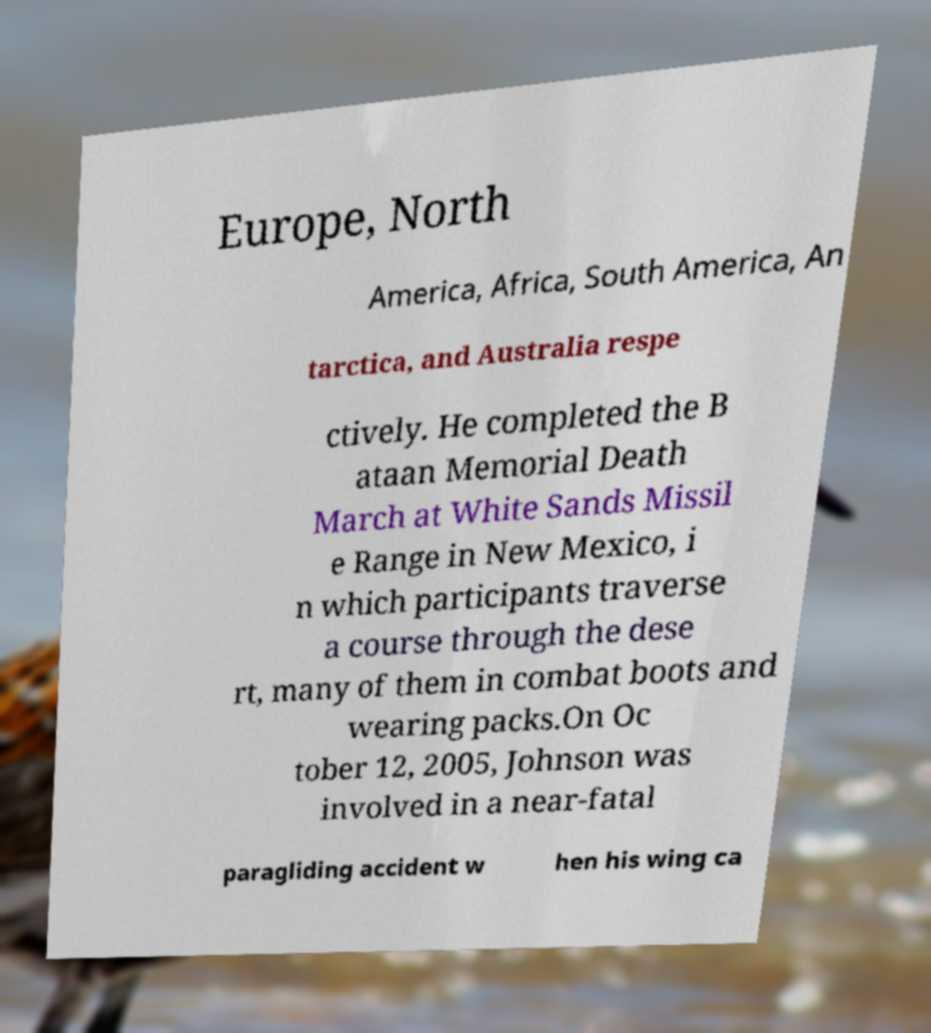Could you assist in decoding the text presented in this image and type it out clearly? Europe, North America, Africa, South America, An tarctica, and Australia respe ctively. He completed the B ataan Memorial Death March at White Sands Missil e Range in New Mexico, i n which participants traverse a course through the dese rt, many of them in combat boots and wearing packs.On Oc tober 12, 2005, Johnson was involved in a near-fatal paragliding accident w hen his wing ca 